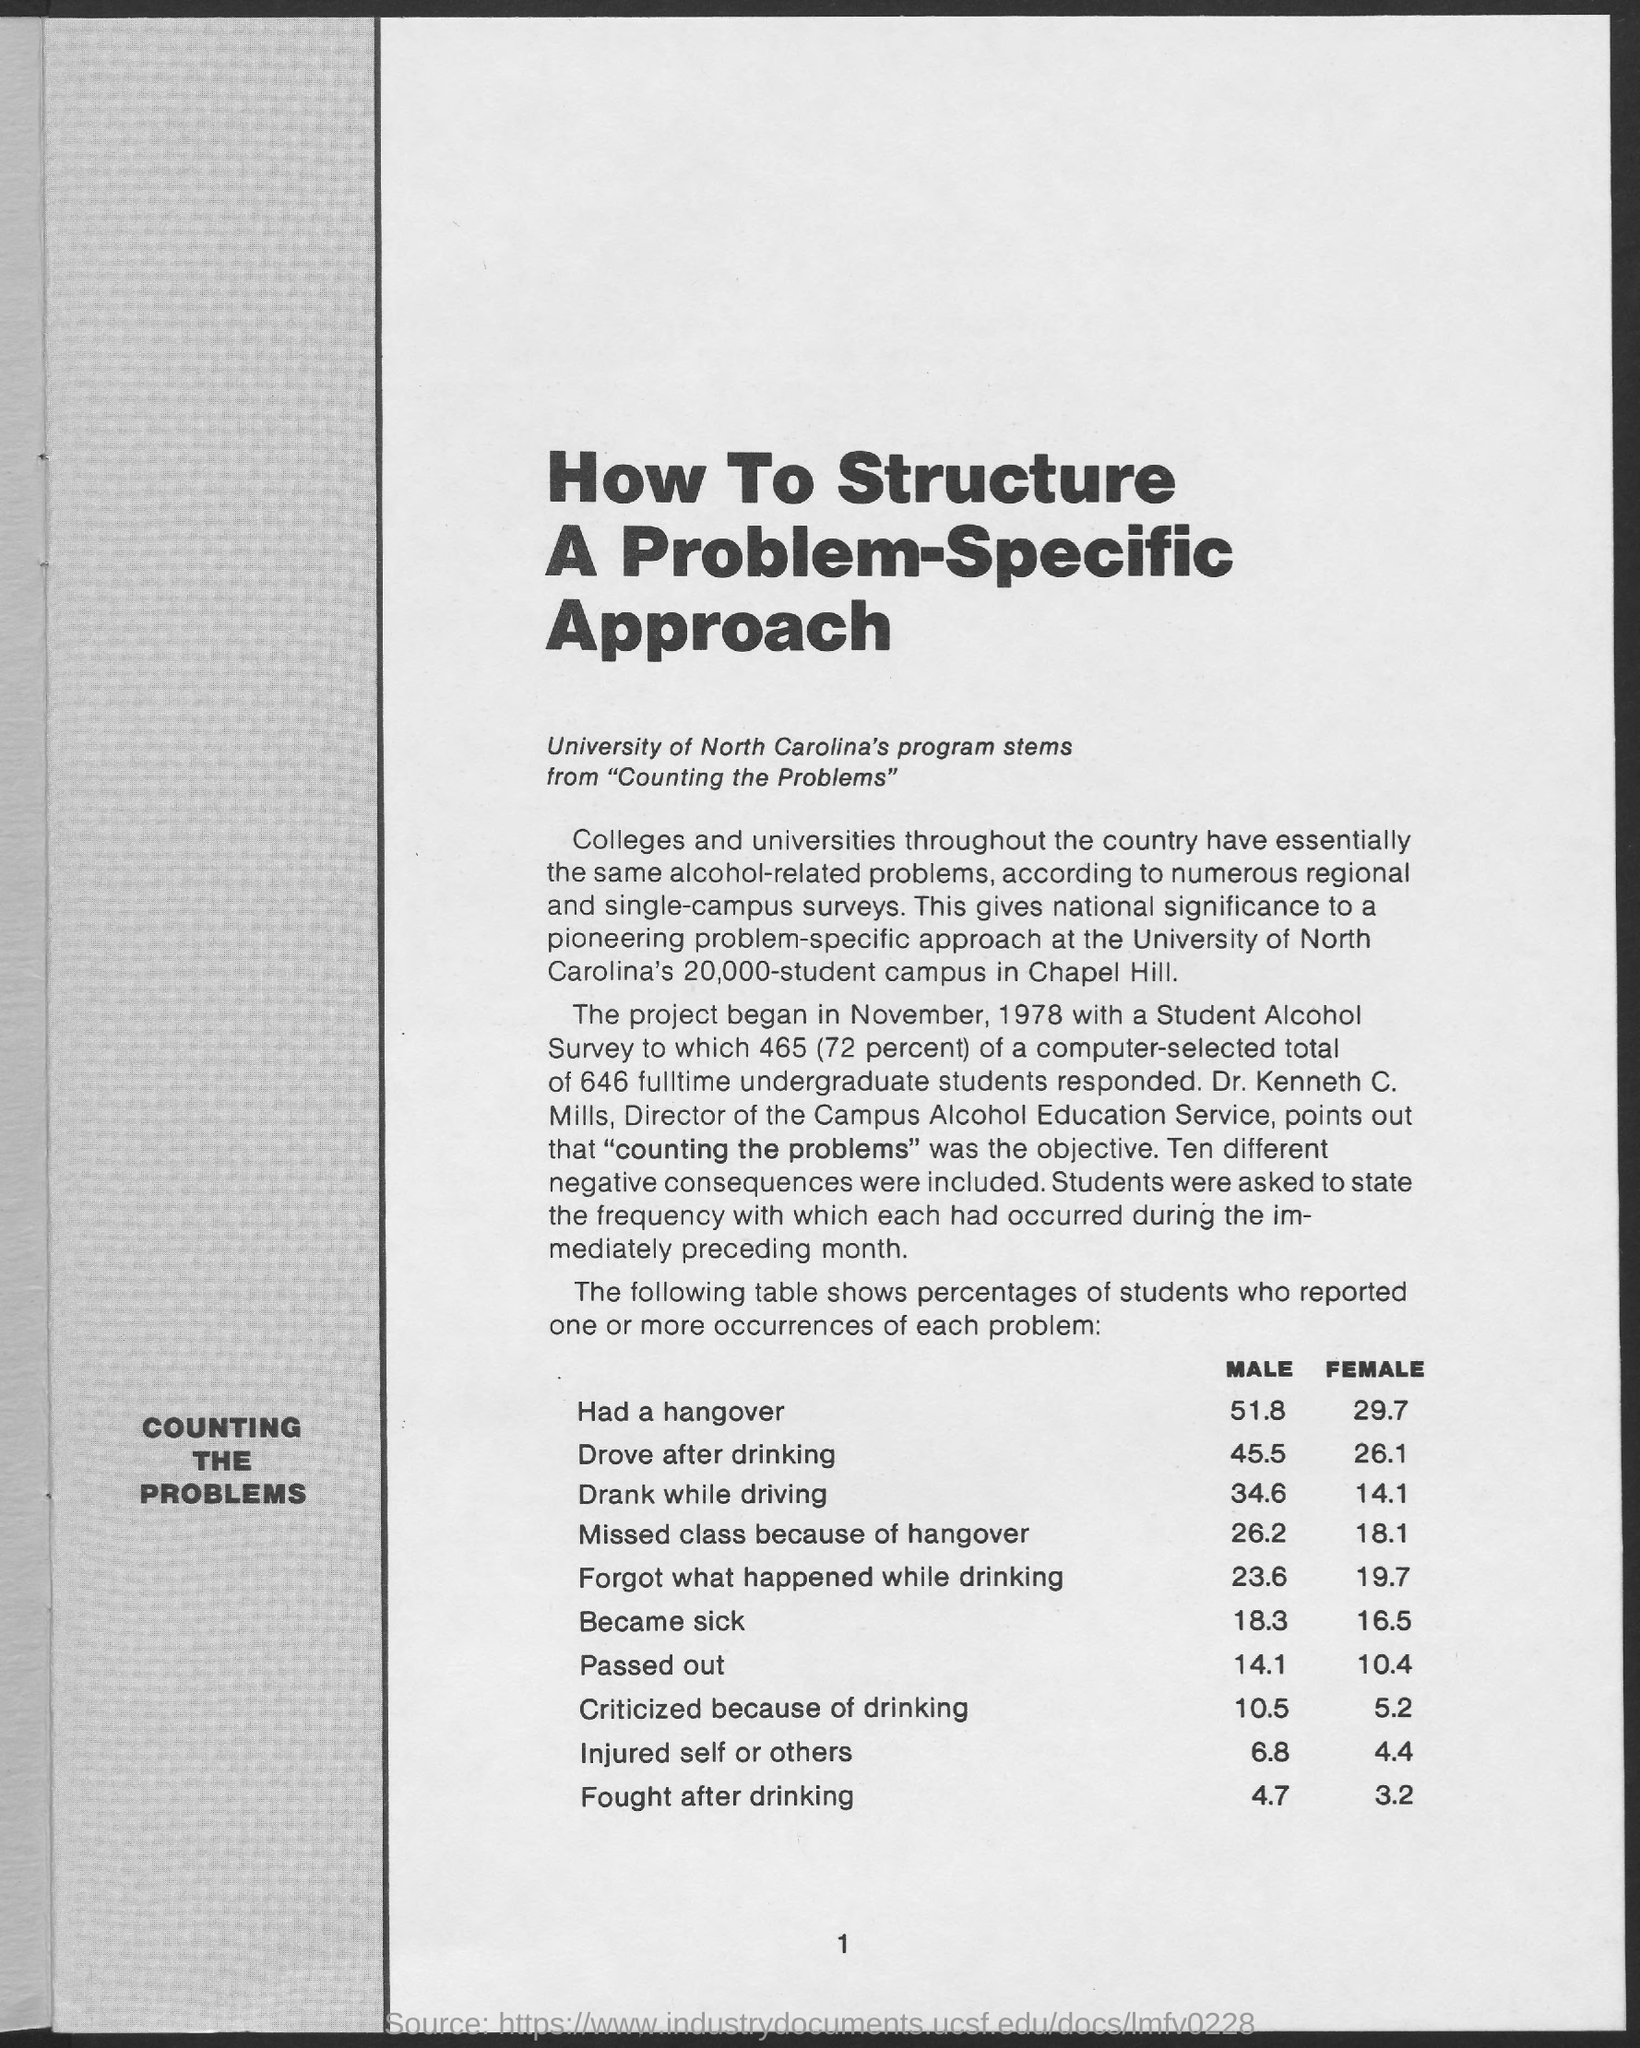Mention a couple of crucial points in this snapshot. According to the table provided, approximately 3.2% of female students reported engaging in physical altercations after consuming alcohol. The page number mentioned in this document is 1.. The main heading of the document is 'How to Structure a Problem-Specific Approach'. A study found that 6.8% of male students had injured themselves or others. The Director of the Campus Alcohol Education Service is Kenneth C. Mills. 